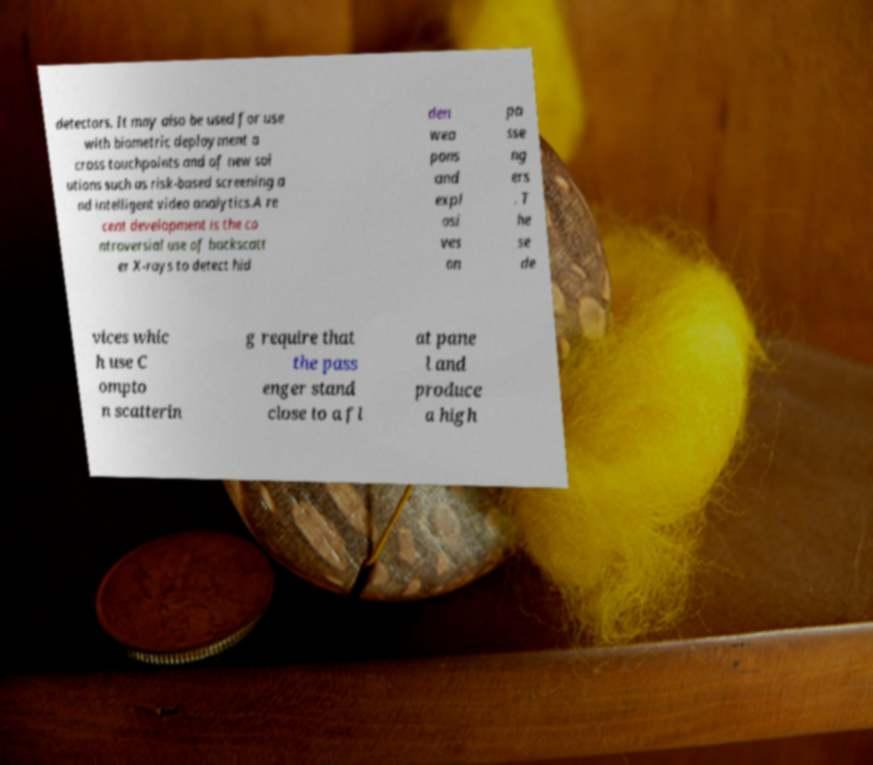For documentation purposes, I need the text within this image transcribed. Could you provide that? detectors. It may also be used for use with biometric deployment a cross touchpoints and of new sol utions such as risk-based screening a nd intelligent video analytics.A re cent development is the co ntroversial use of backscatt er X-rays to detect hid den wea pons and expl osi ves on pa sse ng ers . T he se de vices whic h use C ompto n scatterin g require that the pass enger stand close to a fl at pane l and produce a high 